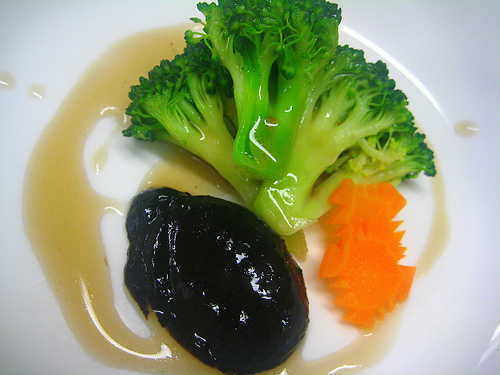Do you see either any cheese or soup there? No, the image features a dish with steamed broccoli, a piece of black-colored food that may be a meat or vegetable in a dark sauce, and carrot slices. There is no cheese or soup visible. 